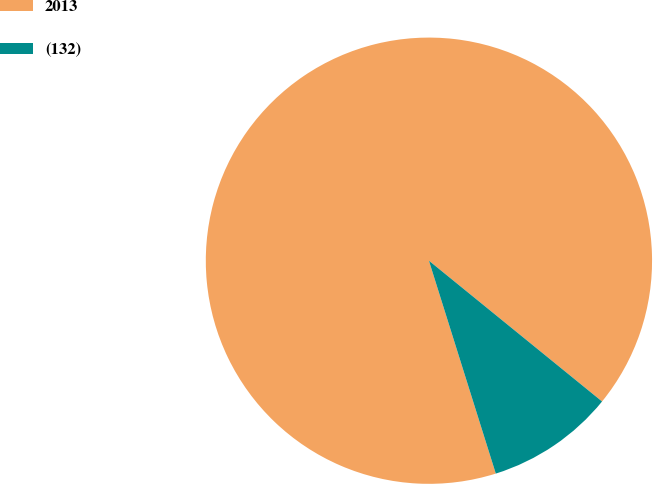<chart> <loc_0><loc_0><loc_500><loc_500><pie_chart><fcel>2013<fcel>(132)<nl><fcel>90.71%<fcel>9.29%<nl></chart> 